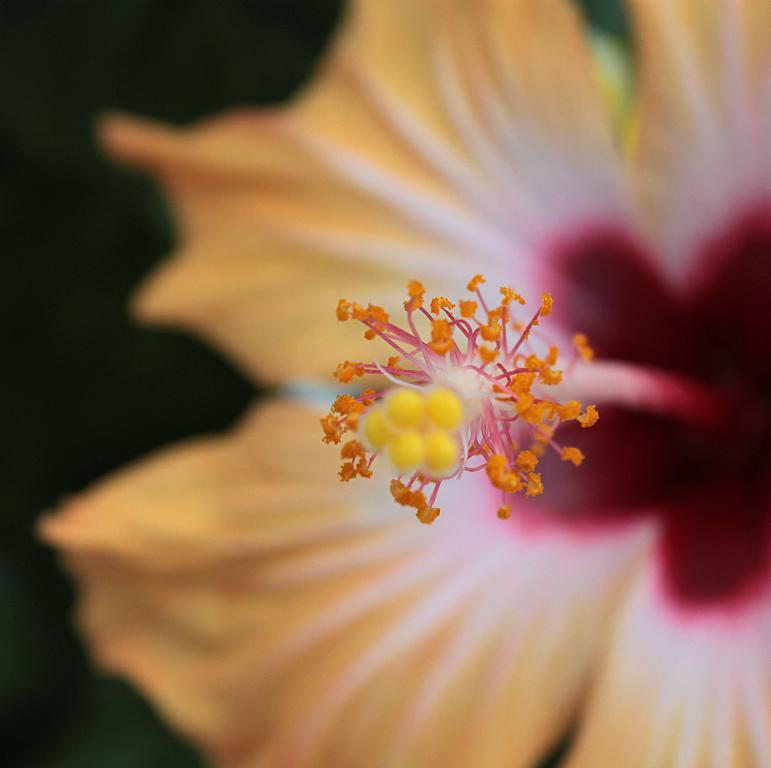What is the main subject of the image? There is a flower in the image. Can you describe the colors of the flower? The flower has yellow and red colors. What color is the background of the image? The background of the image is black. What type of dog can be seen playing with the flower in the image? There is no dog present in the image, and the flower is not being played with. What kind of structure is visible in the background of the image? There is no structure visible in the image, as the background is black. 